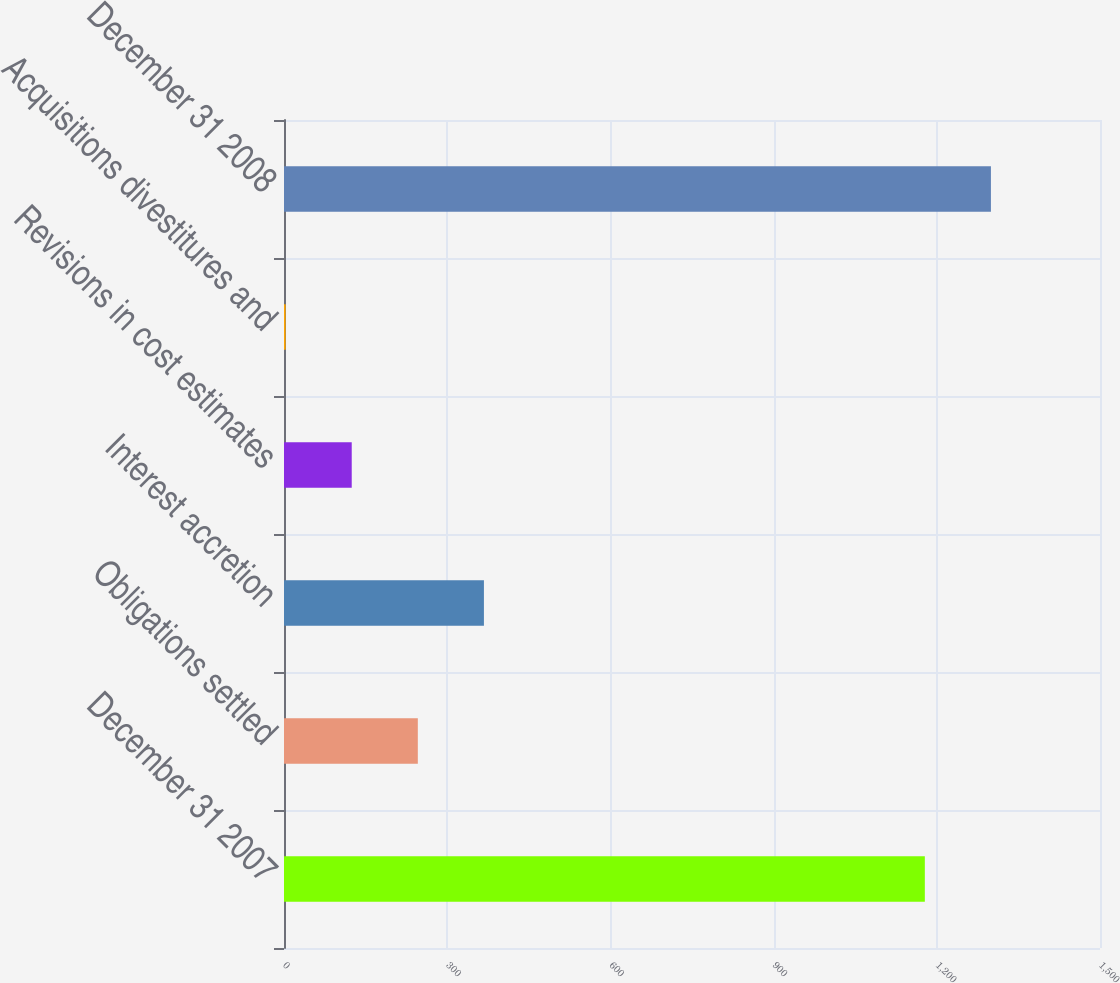Convert chart to OTSL. <chart><loc_0><loc_0><loc_500><loc_500><bar_chart><fcel>December 31 2007<fcel>Obligations settled<fcel>Interest accretion<fcel>Revisions in cost estimates<fcel>Acquisitions divestitures and<fcel>December 31 2008<nl><fcel>1178<fcel>246<fcel>367.5<fcel>124.5<fcel>3<fcel>1299.5<nl></chart> 